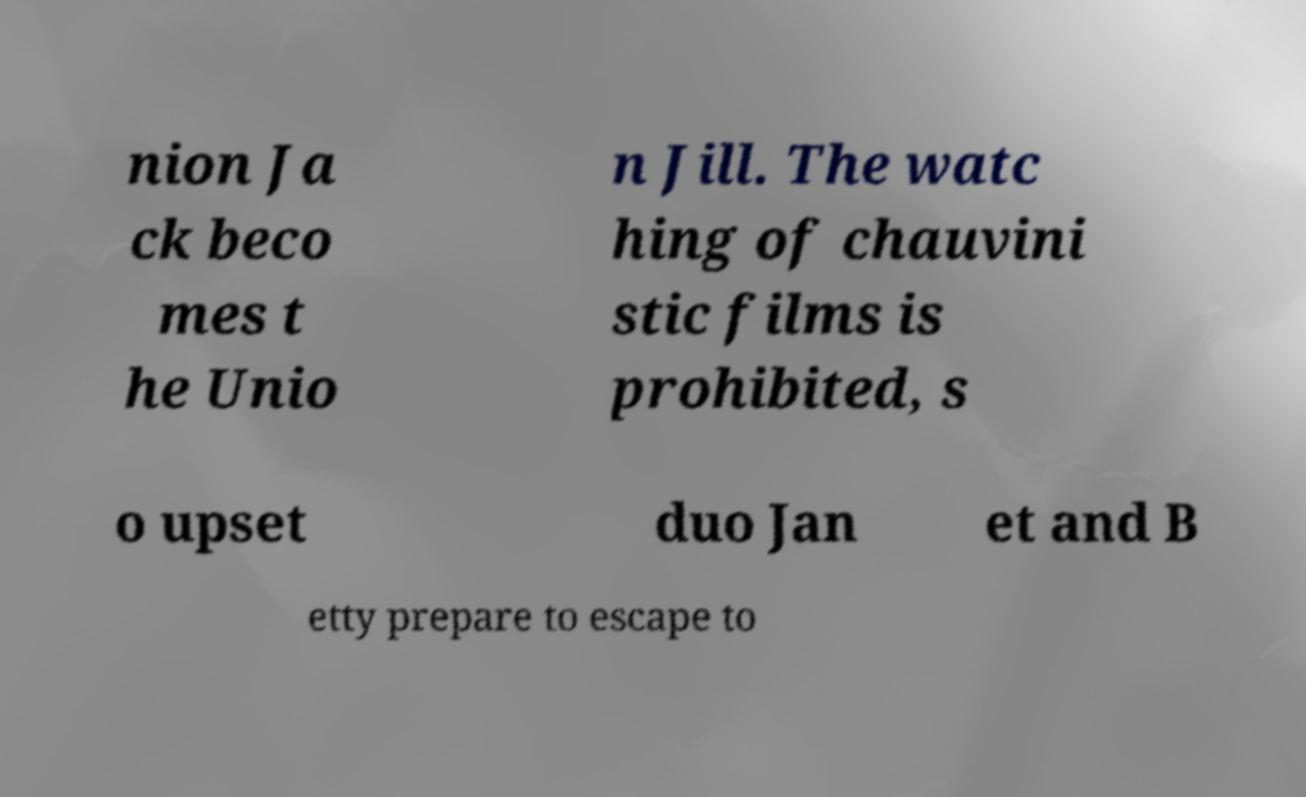Can you accurately transcribe the text from the provided image for me? nion Ja ck beco mes t he Unio n Jill. The watc hing of chauvini stic films is prohibited, s o upset duo Jan et and B etty prepare to escape to 